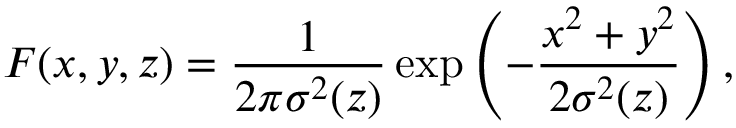<formula> <loc_0><loc_0><loc_500><loc_500>F ( x , y , z ) = \frac { 1 } { 2 \pi \sigma ^ { 2 } ( z ) } \exp \left ( - \frac { x ^ { 2 } + y ^ { 2 } } { 2 \sigma ^ { 2 } ( z ) } \right ) ,</formula> 